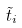<formula> <loc_0><loc_0><loc_500><loc_500>\tilde { t } _ { i }</formula> 